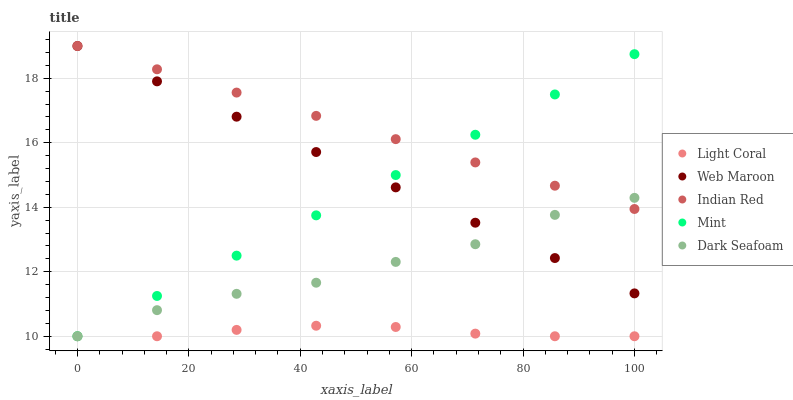Does Light Coral have the minimum area under the curve?
Answer yes or no. Yes. Does Indian Red have the maximum area under the curve?
Answer yes or no. Yes. Does Mint have the minimum area under the curve?
Answer yes or no. No. Does Mint have the maximum area under the curve?
Answer yes or no. No. Is Mint the smoothest?
Answer yes or no. Yes. Is Dark Seafoam the roughest?
Answer yes or no. Yes. Is Dark Seafoam the smoothest?
Answer yes or no. No. Is Mint the roughest?
Answer yes or no. No. Does Light Coral have the lowest value?
Answer yes or no. Yes. Does Web Maroon have the lowest value?
Answer yes or no. No. Does Indian Red have the highest value?
Answer yes or no. Yes. Does Mint have the highest value?
Answer yes or no. No. Is Light Coral less than Web Maroon?
Answer yes or no. Yes. Is Indian Red greater than Light Coral?
Answer yes or no. Yes. Does Mint intersect Dark Seafoam?
Answer yes or no. Yes. Is Mint less than Dark Seafoam?
Answer yes or no. No. Is Mint greater than Dark Seafoam?
Answer yes or no. No. Does Light Coral intersect Web Maroon?
Answer yes or no. No. 